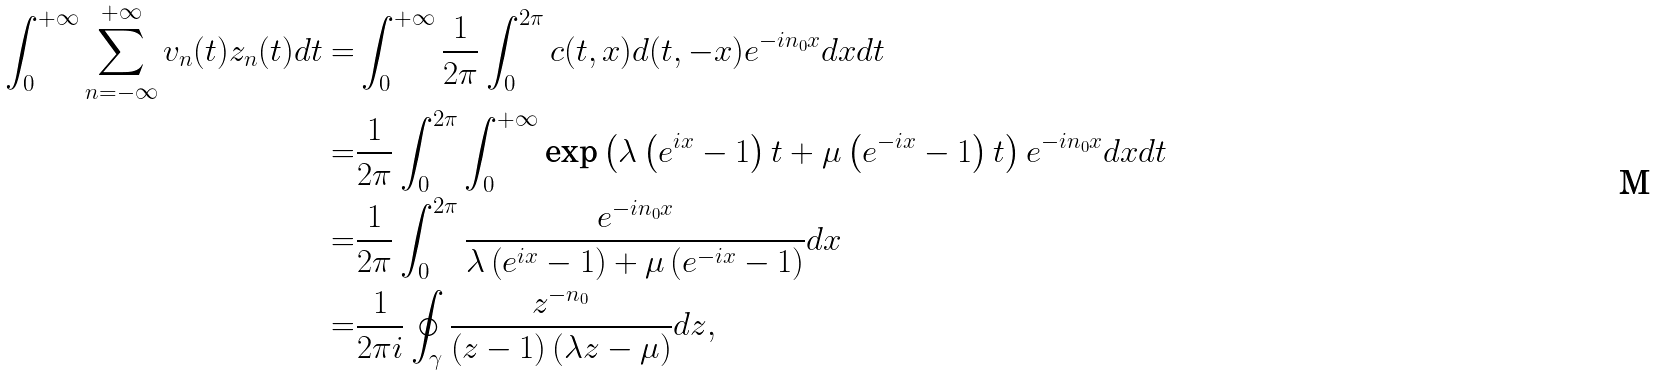Convert formula to latex. <formula><loc_0><loc_0><loc_500><loc_500>\int _ { 0 } ^ { + \infty } \sum _ { n = - \infty } ^ { + \infty } v _ { n } ( t ) z _ { n } ( t ) d t = & \int _ { 0 } ^ { + \infty } \frac { 1 } { 2 \pi } \int _ { 0 } ^ { 2 \pi } c ( t , x ) d ( t , - x ) e ^ { - i n _ { 0 } x } d x d t \\ = & \frac { 1 } { 2 \pi } \int _ { 0 } ^ { 2 \pi } \int _ { 0 } ^ { + \infty } \text {exp} \left ( \lambda \left ( e ^ { i x } - 1 \right ) t + \mu \left ( e ^ { - i x } - 1 \right ) t \right ) e ^ { - i n _ { 0 } x } d x d t \\ = & \frac { 1 } { 2 \pi } \int _ { 0 } ^ { 2 \pi } \frac { e ^ { - i n _ { 0 } x } } { \lambda \left ( e ^ { i x } - 1 \right ) + \mu \left ( e ^ { - i x } - 1 \right ) } d x \\ = & \frac { 1 } { 2 \pi i } \oint _ { \gamma } \frac { z ^ { - n _ { 0 } } } { \left ( z - 1 \right ) \left ( \lambda z - \mu \right ) } d z ,</formula> 